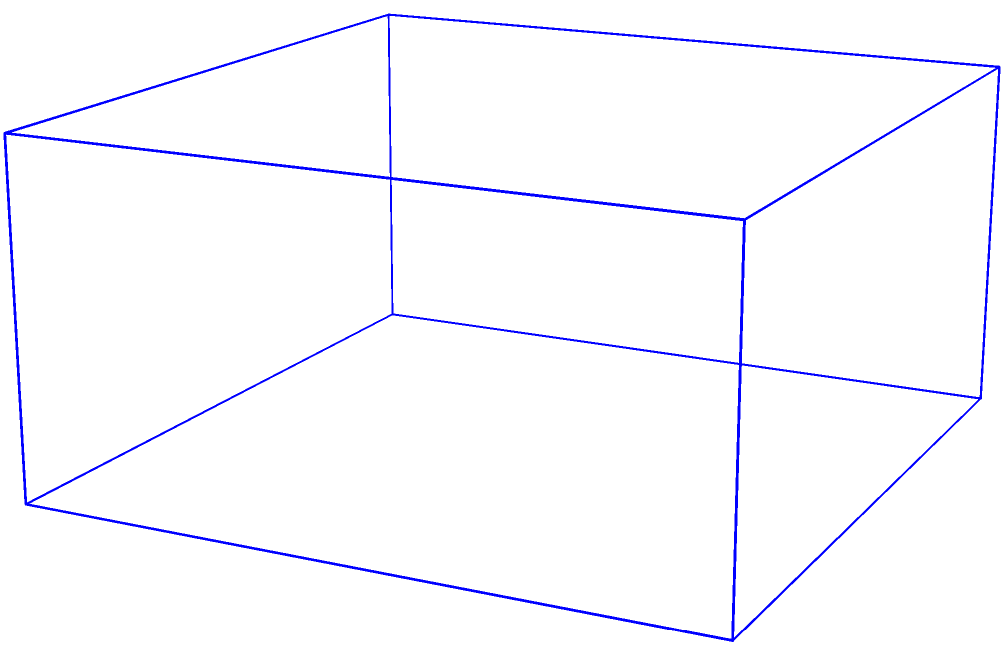As a studio manager overseeing a game development project, you're reviewing different perspective views of a scene. The image shows a game scene with a blue cube, a red cylinder, and a green sphere. Four camera positions (A, B, C, and D) are indicated. Which camera position would provide the best view of all three objects simultaneously, ensuring that the mentor's work on object placement is clearly visible? To determine the best camera position, we need to consider the visibility of all three objects from each perspective:

1. Analyze the scene layout:
   - The blue cube is at the bottom
   - The red cylinder is on top of the cube
   - The green sphere is above and slightly to the side of the cube

2. Evaluate each camera position:
   A (top-right): This view would show the top of the cube and cylinder, but the sphere might be partially obscured.
   B (bottom-right): This view would show the front of the cube and cylinder, but the sphere might be hidden behind them.
   C (top-left): This view would show the top and side of the cube, the cylinder, and the sphere clearly.
   D (bottom-left): This view would show the side of the cube and cylinder, but the sphere might be partially hidden.

3. Consider the visibility of all objects:
   Position C provides the best view of all three objects simultaneously, as it offers a clear line of sight to the top and side of the cube, the cylinder, and the sphere.

4. Think about showcasing the mentor's work:
   Position C allows for the best appreciation of object placement and composition, highlighting the mentor's contributions to the scene layout.
Answer: C 